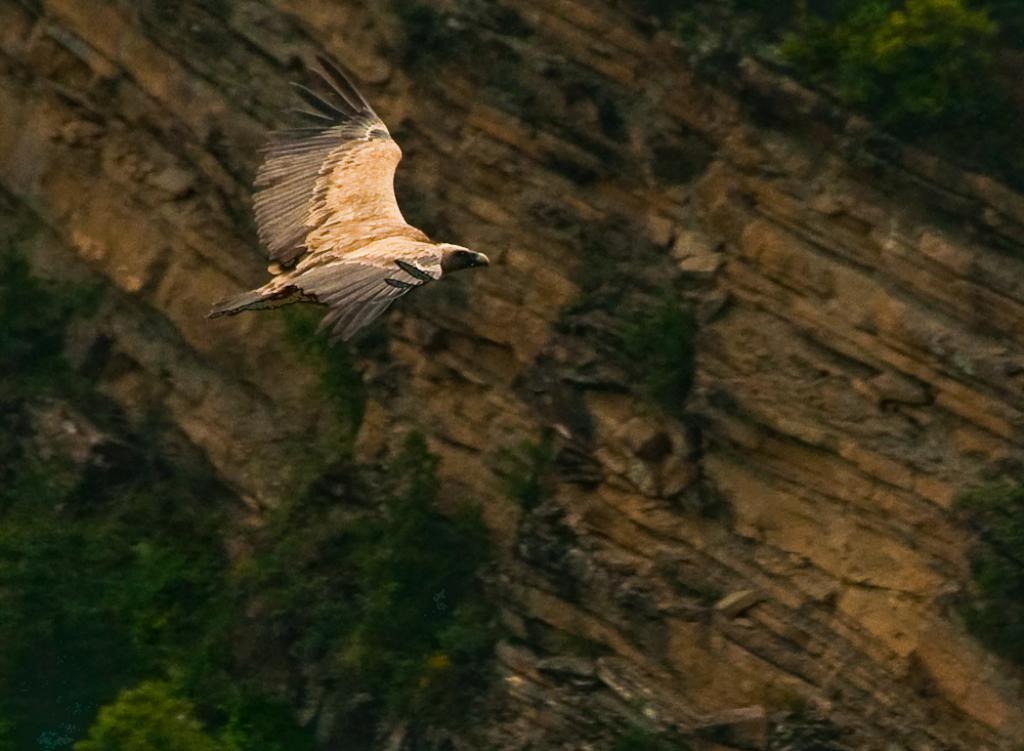Please provide a concise description of this image. This picture is clicked outside. In the center we can see a bird flying in the air. In the foreground we can see the green leaves and some other objects. 